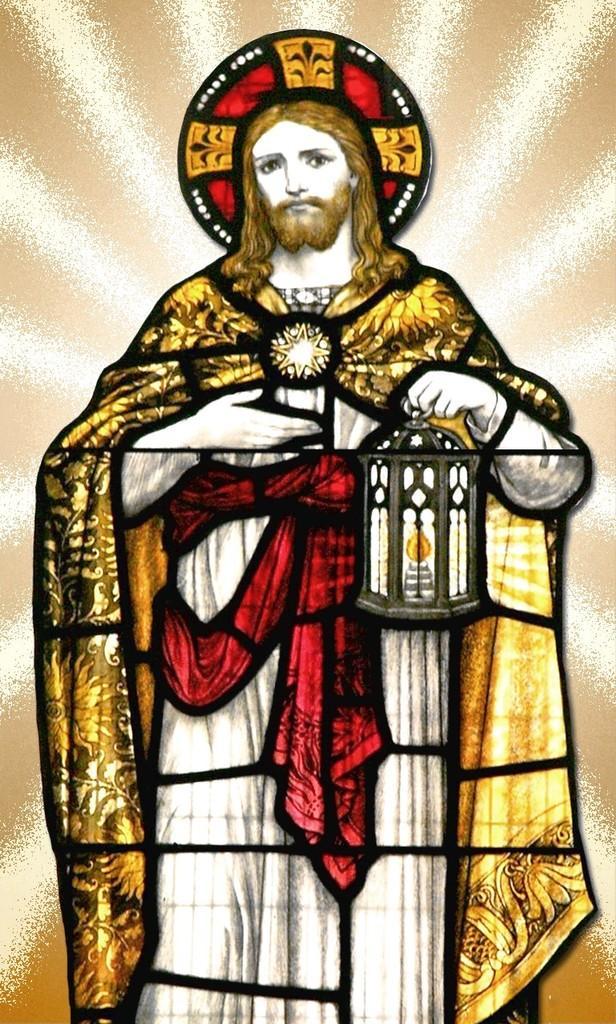Describe this image in one or two sentences. This image contains a painting. In this image, we can see a person is in standing position and the person is holding a lantern in one hand and light in other hand, he is also wearing a cap. In the background, we can see cream color and white color. 